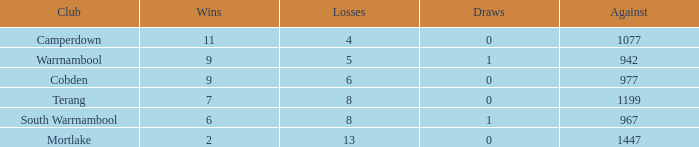How many stalemates did mortlake have when the losses surpassed 5? 1.0. 